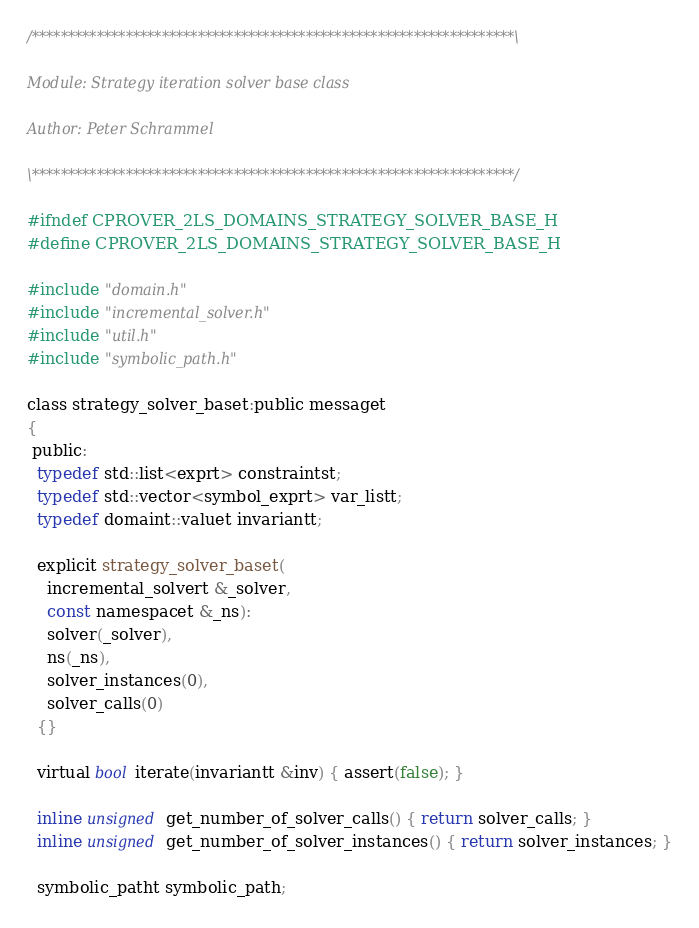Convert code to text. <code><loc_0><loc_0><loc_500><loc_500><_C_>/*******************************************************************\

Module: Strategy iteration solver base class

Author: Peter Schrammel

\*******************************************************************/

#ifndef CPROVER_2LS_DOMAINS_STRATEGY_SOLVER_BASE_H
#define CPROVER_2LS_DOMAINS_STRATEGY_SOLVER_BASE_H

#include "domain.h"
#include "incremental_solver.h"
#include "util.h"
#include "symbolic_path.h"

class strategy_solver_baset:public messaget
{
 public:
  typedef std::list<exprt> constraintst;
  typedef std::vector<symbol_exprt> var_listt;
  typedef domaint::valuet invariantt;

  explicit strategy_solver_baset(
    incremental_solvert &_solver,
    const namespacet &_ns):
    solver(_solver),
    ns(_ns),
    solver_instances(0),
    solver_calls(0)
  {}

  virtual bool iterate(invariantt &inv) { assert(false); }

  inline unsigned get_number_of_solver_calls() { return solver_calls; }
  inline unsigned get_number_of_solver_instances() { return solver_instances; }

  symbolic_patht symbolic_path;
</code> 